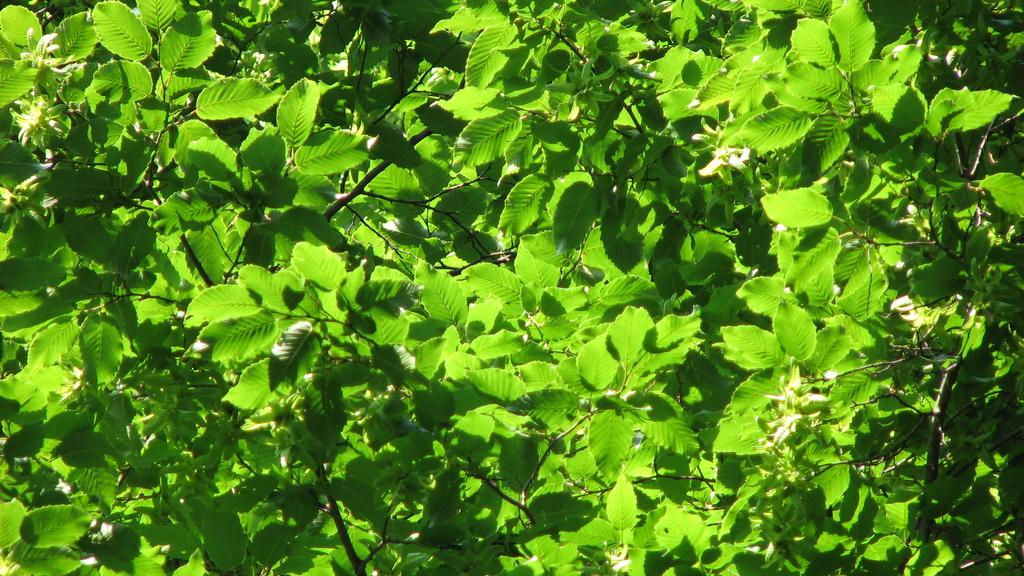What color are the leaves in the image? The leaves in the image are green. What type of lettuce can be seen in the image? There is no lettuce present in the image; it only features green color leaves. What is the value of the cord in the image? There is no cord present in the image, so it is not possible to determine its value. 